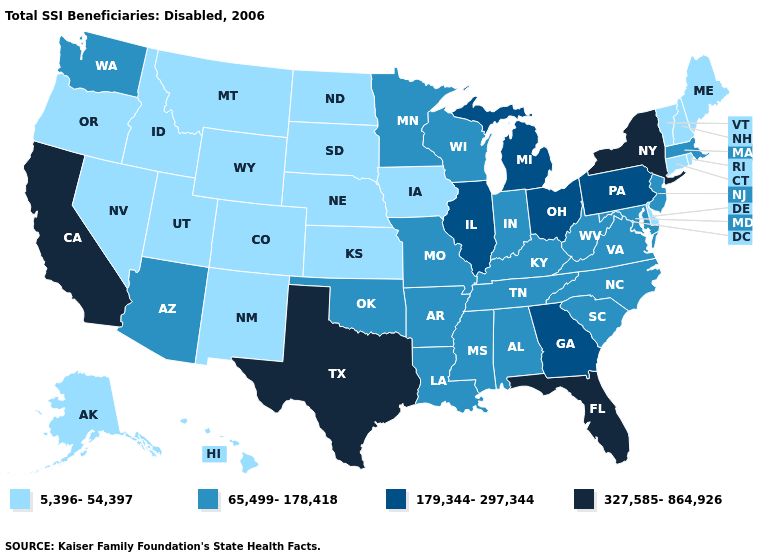Name the states that have a value in the range 179,344-297,344?
Concise answer only. Georgia, Illinois, Michigan, Ohio, Pennsylvania. Does New York have the highest value in the Northeast?
Write a very short answer. Yes. Does South Carolina have a higher value than Texas?
Quick response, please. No. What is the value of Kansas?
Be succinct. 5,396-54,397. Does Arizona have the lowest value in the West?
Short answer required. No. Name the states that have a value in the range 179,344-297,344?
Give a very brief answer. Georgia, Illinois, Michigan, Ohio, Pennsylvania. Among the states that border New York , which have the lowest value?
Write a very short answer. Connecticut, Vermont. Name the states that have a value in the range 327,585-864,926?
Concise answer only. California, Florida, New York, Texas. Which states have the highest value in the USA?
Be succinct. California, Florida, New York, Texas. Which states have the lowest value in the USA?
Be succinct. Alaska, Colorado, Connecticut, Delaware, Hawaii, Idaho, Iowa, Kansas, Maine, Montana, Nebraska, Nevada, New Hampshire, New Mexico, North Dakota, Oregon, Rhode Island, South Dakota, Utah, Vermont, Wyoming. What is the lowest value in the West?
Quick response, please. 5,396-54,397. What is the value of Pennsylvania?
Give a very brief answer. 179,344-297,344. Name the states that have a value in the range 65,499-178,418?
Keep it brief. Alabama, Arizona, Arkansas, Indiana, Kentucky, Louisiana, Maryland, Massachusetts, Minnesota, Mississippi, Missouri, New Jersey, North Carolina, Oklahoma, South Carolina, Tennessee, Virginia, Washington, West Virginia, Wisconsin. How many symbols are there in the legend?
Be succinct. 4. Does North Dakota have the lowest value in the USA?
Keep it brief. Yes. 